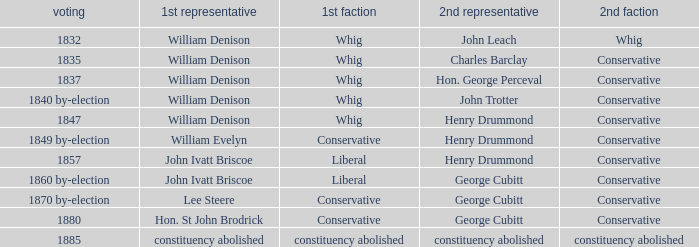Which party's 1st member is William Denison in the election of 1832? Whig. 